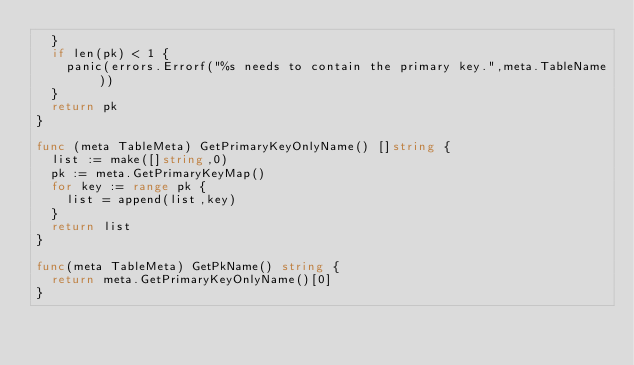Convert code to text. <code><loc_0><loc_0><loc_500><loc_500><_Go_>	}
	if len(pk) < 1 {
		panic(errors.Errorf("%s needs to contain the primary key.",meta.TableName))
	}
	return pk
}

func (meta TableMeta) GetPrimaryKeyOnlyName() []string {
	list := make([]string,0)
	pk := meta.GetPrimaryKeyMap()
	for key := range pk {
		list = append(list,key)
	}
	return list
}

func(meta TableMeta) GetPkName() string {
	return meta.GetPrimaryKeyOnlyName()[0]
}</code> 